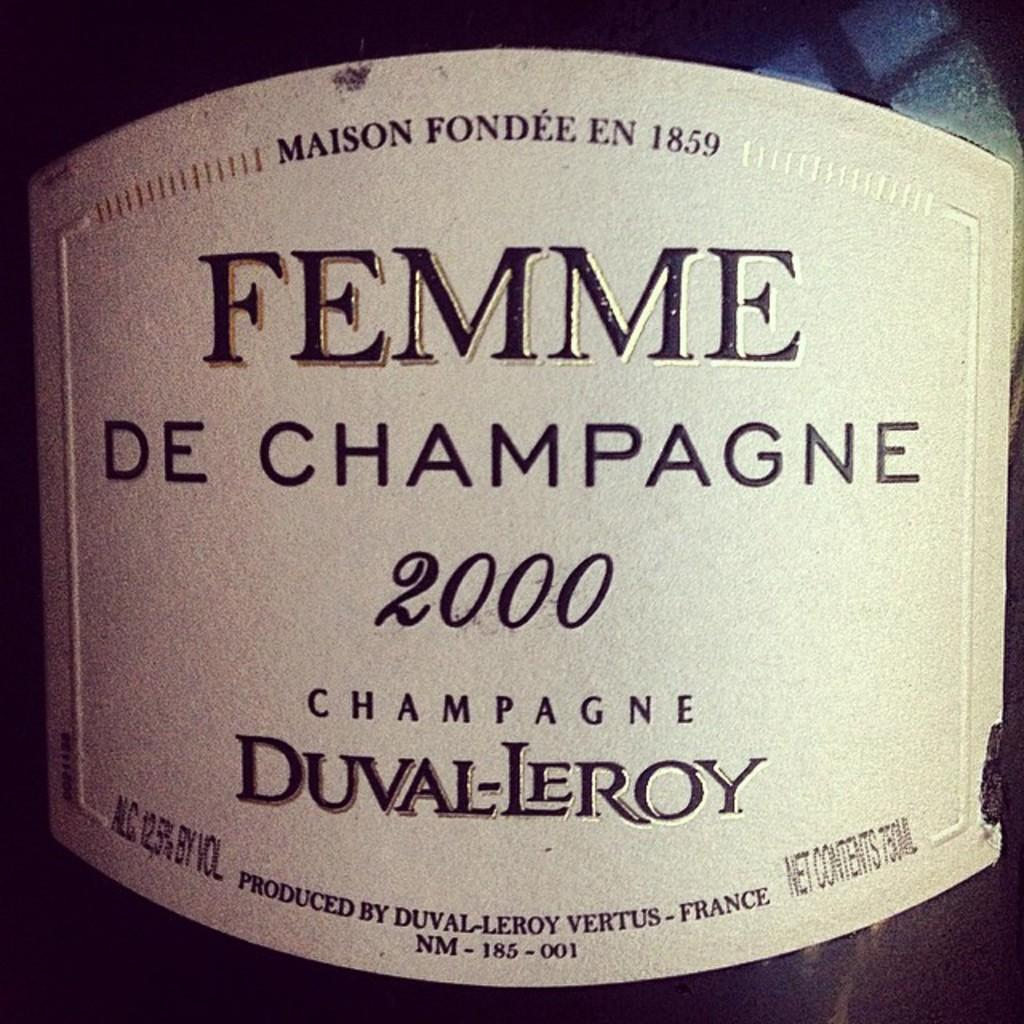<image>
Relay a brief, clear account of the picture shown. the word femme that is on a bottle 